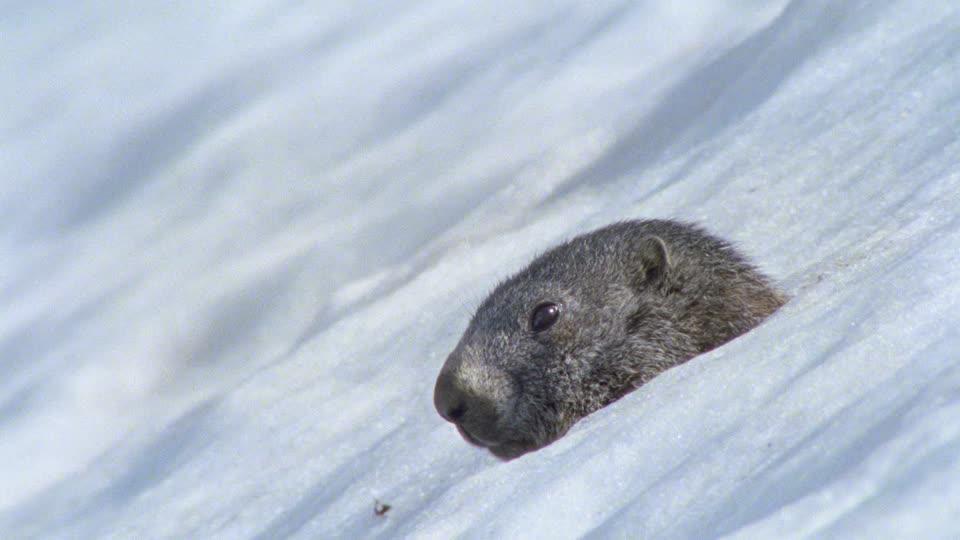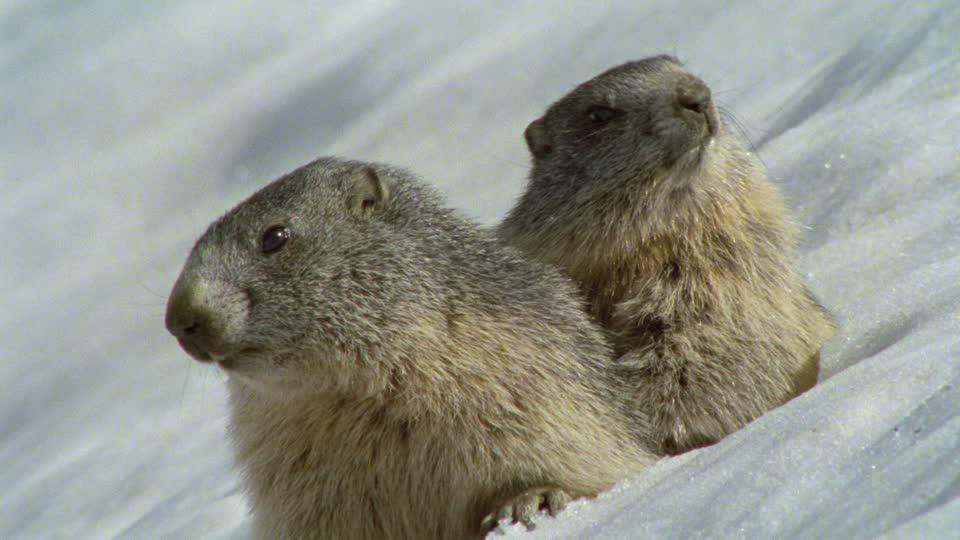The first image is the image on the left, the second image is the image on the right. For the images displayed, is the sentence "The left image contains exactly one rodent in the snow." factually correct? Answer yes or no. Yes. The first image is the image on the left, the second image is the image on the right. For the images shown, is this caption "An image shows a single close-mouthed marmot poking its head up out of the snow." true? Answer yes or no. Yes. 